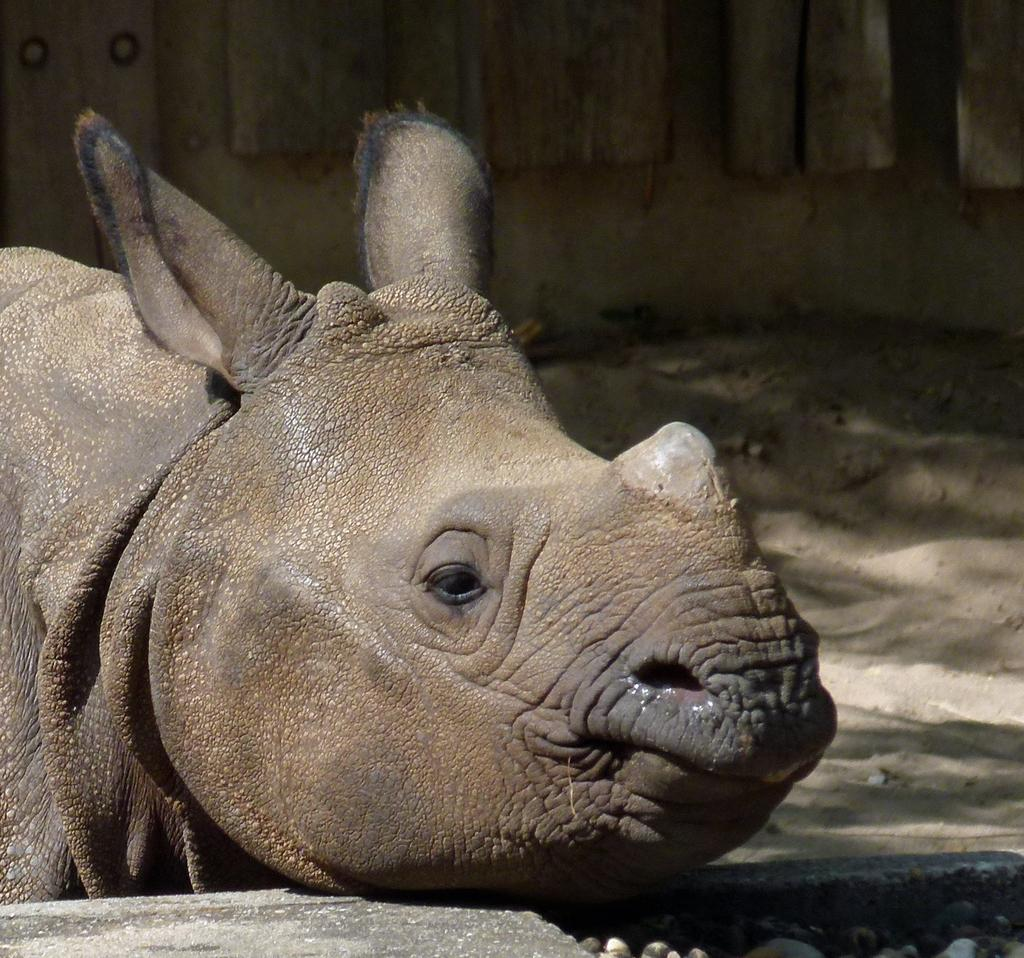What type of creature is present in the image? There is an animal in the image. Where is the animal located in the image? The animal is sitting in a place. What is the animal's focus in the image? The animal is looking at something. How many oranges are being held by the animal in the image? There are no oranges present in the image. What type of border surrounds the animal in the image? There is no border surrounding the animal in the image. 